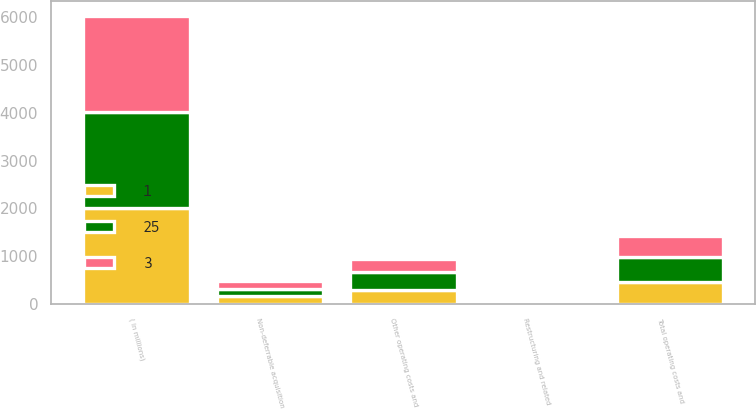Convert chart to OTSL. <chart><loc_0><loc_0><loc_500><loc_500><stacked_bar_chart><ecel><fcel>( in millions)<fcel>Non-deferrable acquisition<fcel>Other operating costs and<fcel>Total operating costs and<fcel>Restructuring and related<nl><fcel>1<fcel>2010<fcel>168<fcel>301<fcel>469<fcel>3<nl><fcel>3<fcel>2009<fcel>156<fcel>274<fcel>430<fcel>25<nl><fcel>25<fcel>2008<fcel>153<fcel>367<fcel>520<fcel>1<nl></chart> 